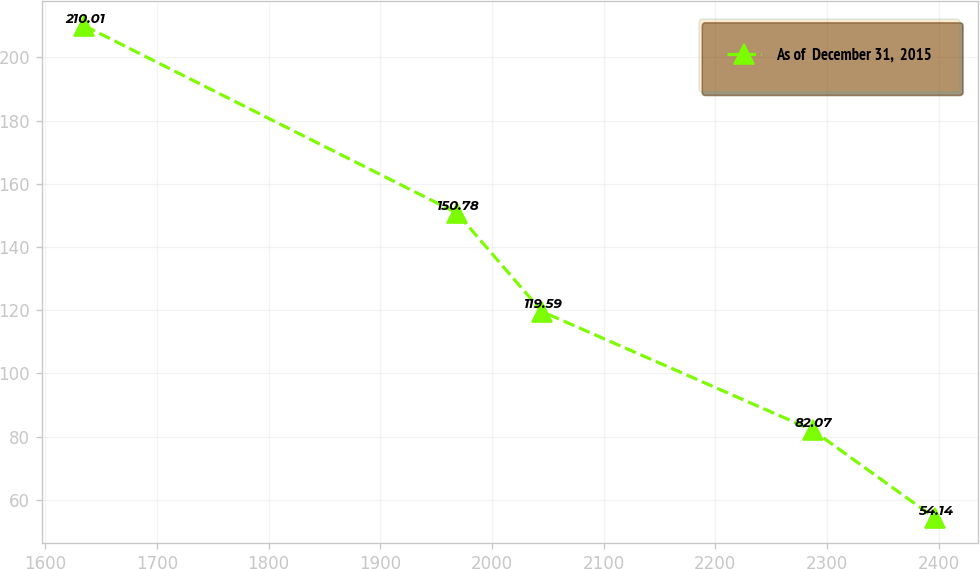<chart> <loc_0><loc_0><loc_500><loc_500><line_chart><ecel><fcel>As of  December 31,  2015<nl><fcel>1635.04<fcel>210.01<nl><fcel>1968.55<fcel>150.78<nl><fcel>2044.76<fcel>119.59<nl><fcel>2287.1<fcel>82.07<nl><fcel>2397.11<fcel>54.14<nl></chart> 